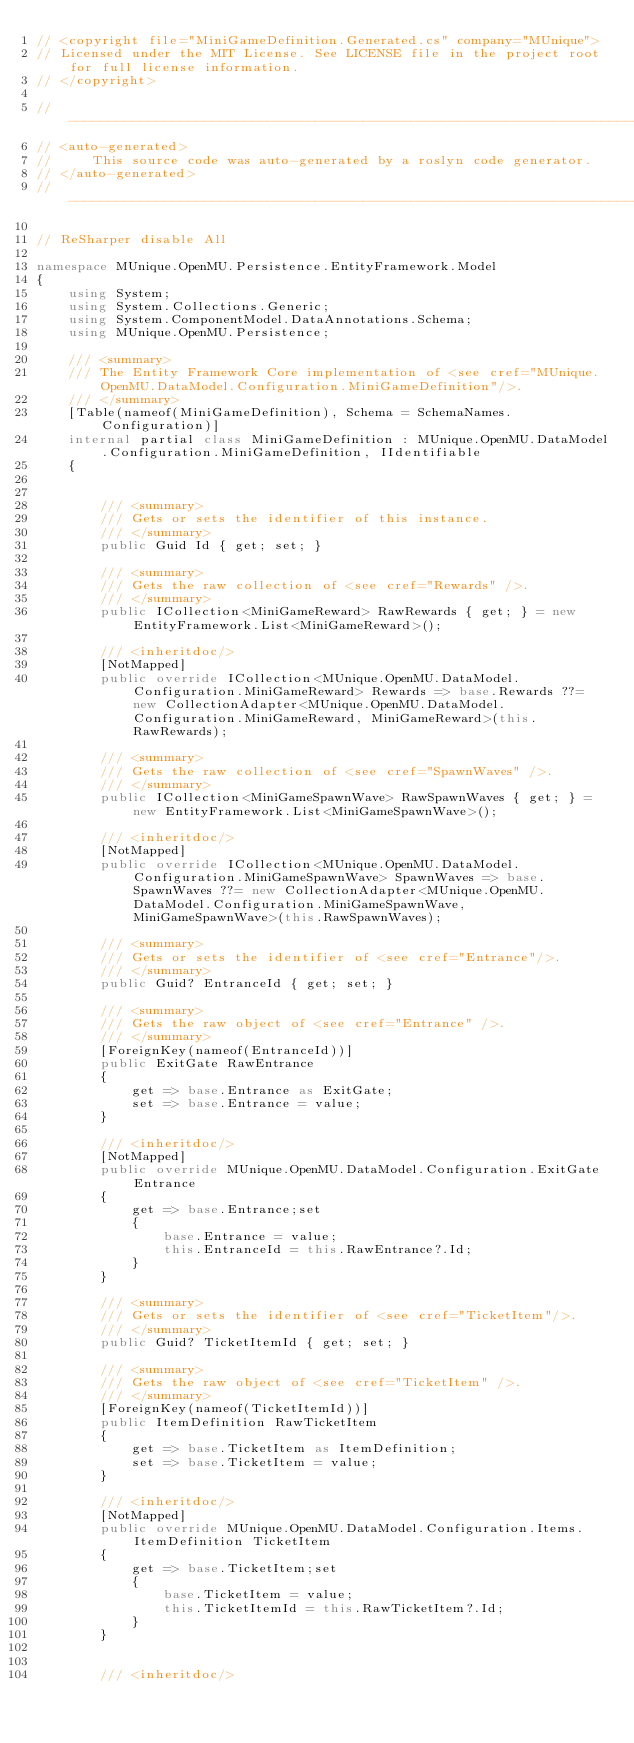Convert code to text. <code><loc_0><loc_0><loc_500><loc_500><_C#_>// <copyright file="MiniGameDefinition.Generated.cs" company="MUnique">
// Licensed under the MIT License. See LICENSE file in the project root for full license information.
// </copyright>

//------------------------------------------------------------------------------
// <auto-generated>
//     This source code was auto-generated by a roslyn code generator.
// </auto-generated>
//------------------------------------------------------------------------------

// ReSharper disable All

namespace MUnique.OpenMU.Persistence.EntityFramework.Model
{
    using System;
    using System.Collections.Generic;
    using System.ComponentModel.DataAnnotations.Schema;
    using MUnique.OpenMU.Persistence;
    
    /// <summary>
    /// The Entity Framework Core implementation of <see cref="MUnique.OpenMU.DataModel.Configuration.MiniGameDefinition"/>.
    /// </summary>
    [Table(nameof(MiniGameDefinition), Schema = SchemaNames.Configuration)]
    internal partial class MiniGameDefinition : MUnique.OpenMU.DataModel.Configuration.MiniGameDefinition, IIdentifiable
    {
        
        
        /// <summary>
        /// Gets or sets the identifier of this instance.
        /// </summary>
        public Guid Id { get; set; }
        
        /// <summary>
        /// Gets the raw collection of <see cref="Rewards" />.
        /// </summary>
        public ICollection<MiniGameReward> RawRewards { get; } = new EntityFramework.List<MiniGameReward>();
        
        /// <inheritdoc/>
        [NotMapped]
        public override ICollection<MUnique.OpenMU.DataModel.Configuration.MiniGameReward> Rewards => base.Rewards ??= new CollectionAdapter<MUnique.OpenMU.DataModel.Configuration.MiniGameReward, MiniGameReward>(this.RawRewards);

        /// <summary>
        /// Gets the raw collection of <see cref="SpawnWaves" />.
        /// </summary>
        public ICollection<MiniGameSpawnWave> RawSpawnWaves { get; } = new EntityFramework.List<MiniGameSpawnWave>();
        
        /// <inheritdoc/>
        [NotMapped]
        public override ICollection<MUnique.OpenMU.DataModel.Configuration.MiniGameSpawnWave> SpawnWaves => base.SpawnWaves ??= new CollectionAdapter<MUnique.OpenMU.DataModel.Configuration.MiniGameSpawnWave, MiniGameSpawnWave>(this.RawSpawnWaves);

        /// <summary>
        /// Gets or sets the identifier of <see cref="Entrance"/>.
        /// </summary>
        public Guid? EntranceId { get; set; }

        /// <summary>
        /// Gets the raw object of <see cref="Entrance" />.
        /// </summary>
        [ForeignKey(nameof(EntranceId))]
        public ExitGate RawEntrance
        {
            get => base.Entrance as ExitGate;
            set => base.Entrance = value;
        }

        /// <inheritdoc/>
        [NotMapped]
        public override MUnique.OpenMU.DataModel.Configuration.ExitGate Entrance
        {
            get => base.Entrance;set
            {
                base.Entrance = value;
                this.EntranceId = this.RawEntrance?.Id;
            }
        }

        /// <summary>
        /// Gets or sets the identifier of <see cref="TicketItem"/>.
        /// </summary>
        public Guid? TicketItemId { get; set; }

        /// <summary>
        /// Gets the raw object of <see cref="TicketItem" />.
        /// </summary>
        [ForeignKey(nameof(TicketItemId))]
        public ItemDefinition RawTicketItem
        {
            get => base.TicketItem as ItemDefinition;
            set => base.TicketItem = value;
        }

        /// <inheritdoc/>
        [NotMapped]
        public override MUnique.OpenMU.DataModel.Configuration.Items.ItemDefinition TicketItem
        {
            get => base.TicketItem;set
            {
                base.TicketItem = value;
                this.TicketItemId = this.RawTicketItem?.Id;
            }
        }


        /// <inheritdoc/></code> 